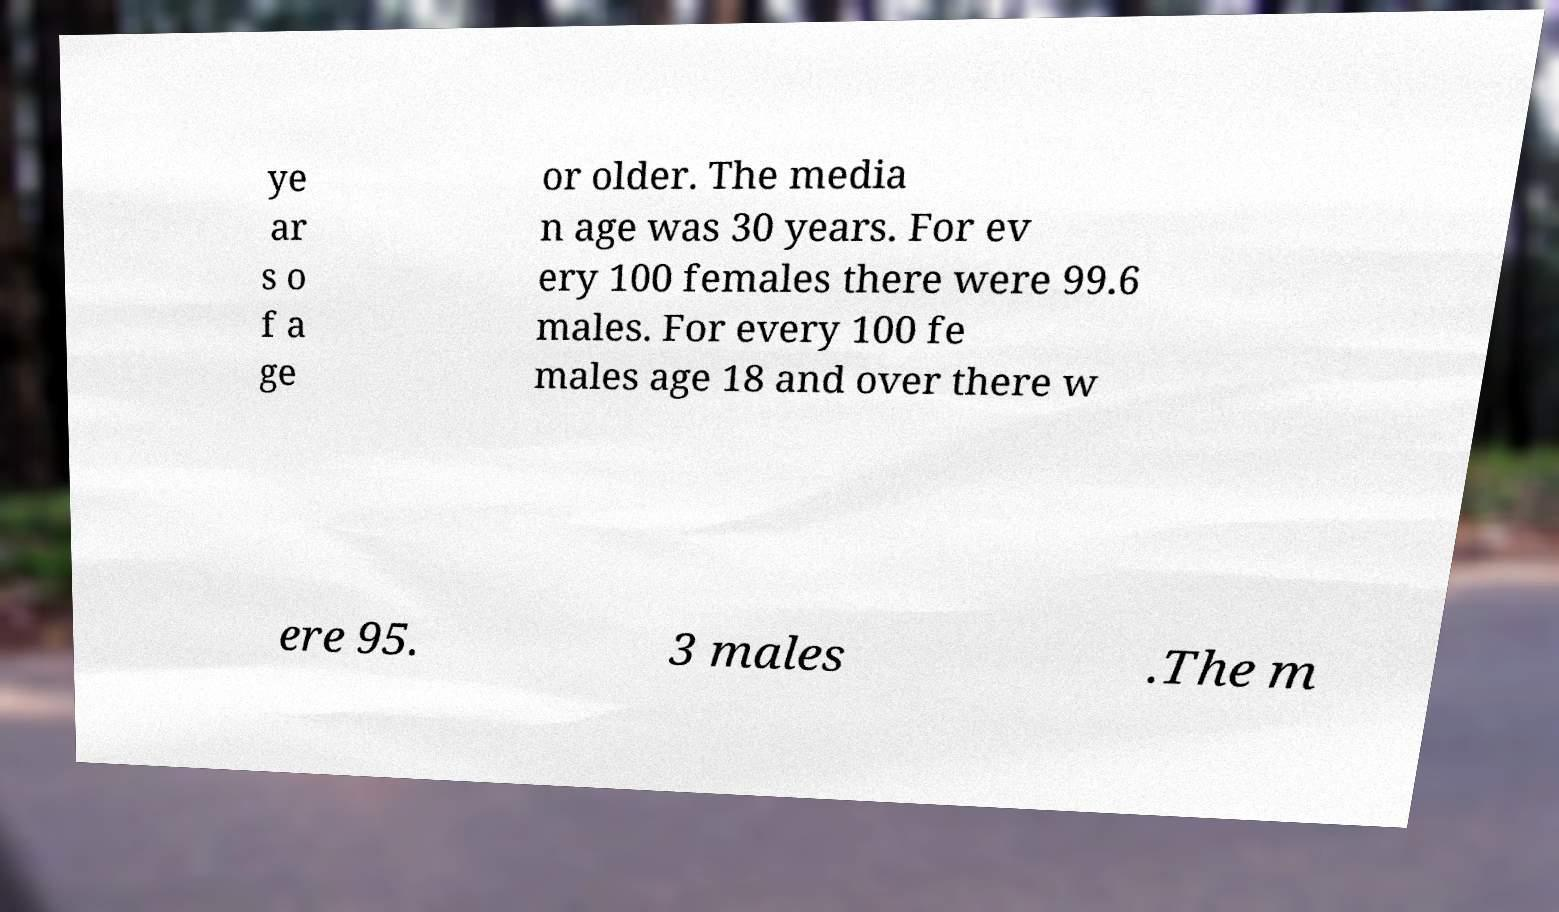I need the written content from this picture converted into text. Can you do that? ye ar s o f a ge or older. The media n age was 30 years. For ev ery 100 females there were 99.6 males. For every 100 fe males age 18 and over there w ere 95. 3 males .The m 